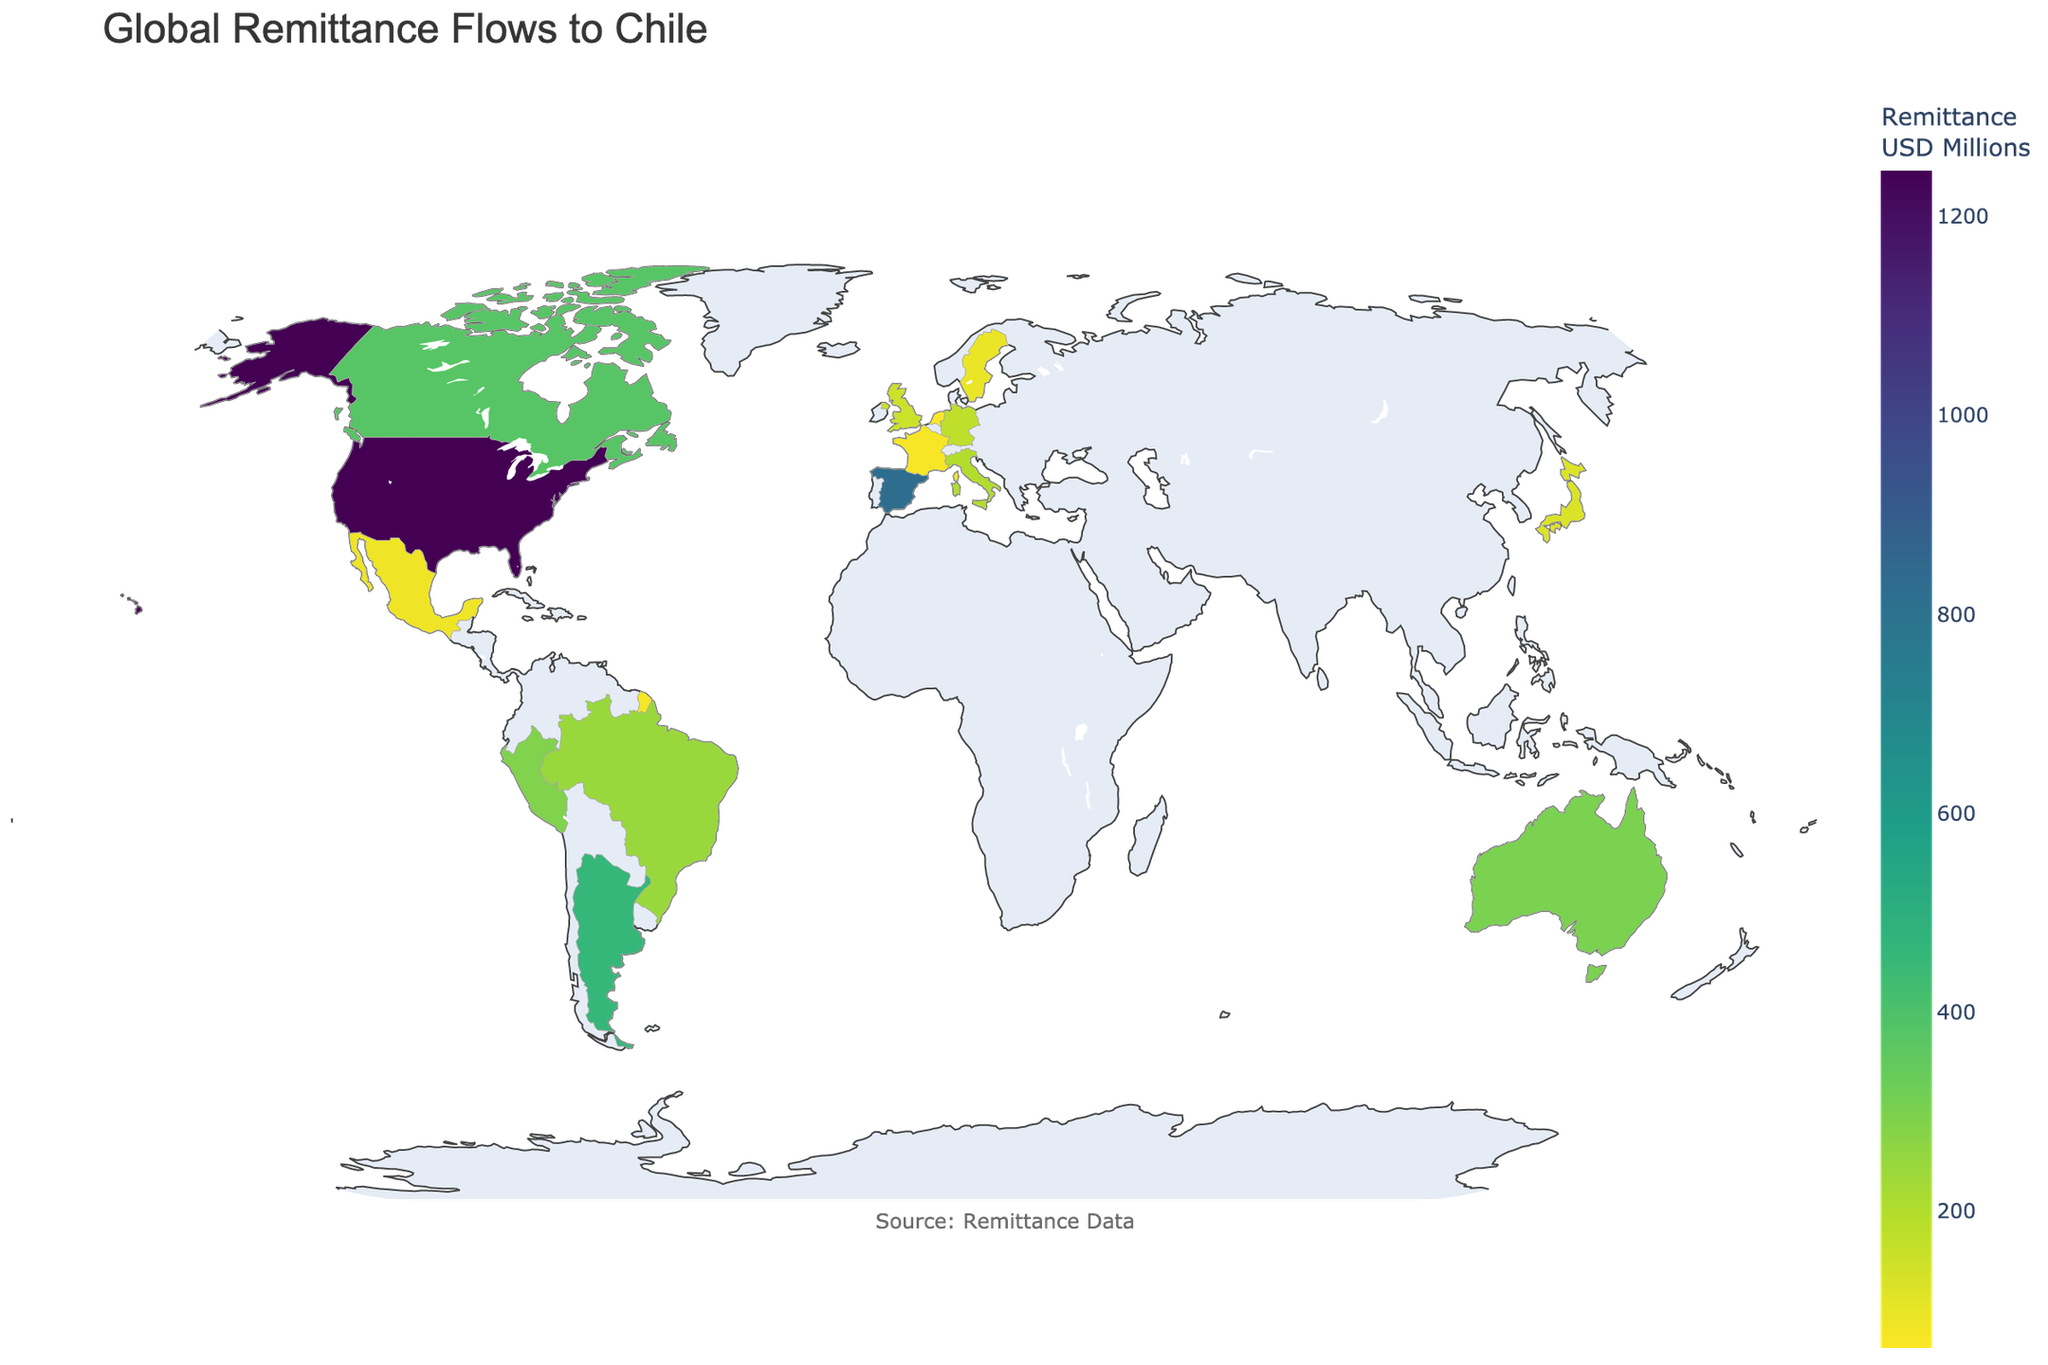What's the title of the figure? The title is usually displayed prominently at the top of the plot. In this case, it reads "Global Remittance Flows to Chile."
Answer: Global Remittance Flows to Chile How much money is remitted to Chile from the United States? Locate the United States on the map and check the hover text value for "Remittance: $1245.6 Million".
Answer: $1245.6 Million Which country has the second highest remittance to Chile? First identify the highest remittance which is from the United States. Then find the next highest value, which is from Spain.
Answer: Spain What is the total remittance from Argentina and Canada combined? Find the values for Argentina ($456.2 Million) and Canada ($378.5 Million) and sum them up. The total is $456.2M + $378.5M = $834.7M.
Answer: $834.7 Million What is the color used in the figure to represent different remittance values? The figure uses a color scale named 'Viridis'. Typically, lighter colors represent lower values and darker colors represent higher values.
Answer: Viridis colorscale Which European country sends more remittance to Chile, Germany or Italy? Identify the values for Germany ($176.4 Million) and Italy ($198.6 Million). Italy has a higher remittance value.
Answer: Italy How many countries in total are shown in the remittance data to Chile? Count the total number of data points representing different countries in the figure. There are 15 countries listed.
Answer: 15 What is the average remittance amount from the countries listed in the data? Sum all the remittance values and then divide by the number of countries. The sum is $1245.6M (US) + $823.9M (Spain) + $456.2M (Argentina) + $378.5M (Canada) + $302.1M (Australia) + $289.7M (Peru) + $245.3M (Brazil) + $198.6M (Italy) + $176.4M (Germany) + $152.8M (UK) + $124.5M (Japan) + $98.3M (Sweden) + $87.6M (Mexico) + $76.2M (France) + $62.9M (Netherlands) = $4718.6M. Average = $4718.6M / 15 = $314.57M.
Answer: $314.57 Million Which country has the lowest remittance value to Chile? Identify the country with the smallest remittance value. From the data, it is the Netherlands with $62.9 Million.
Answer: Netherlands 